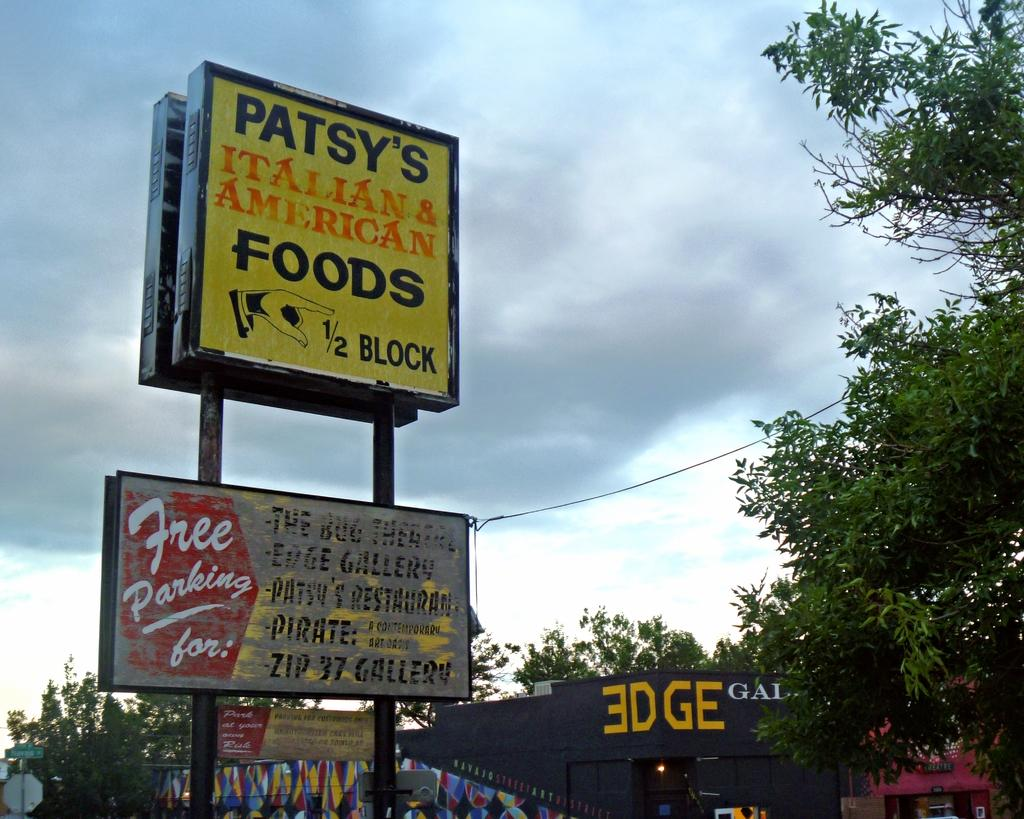<image>
Describe the image concisely. A 3DGE store with a sign for Patsy's Italian & American food above it. 